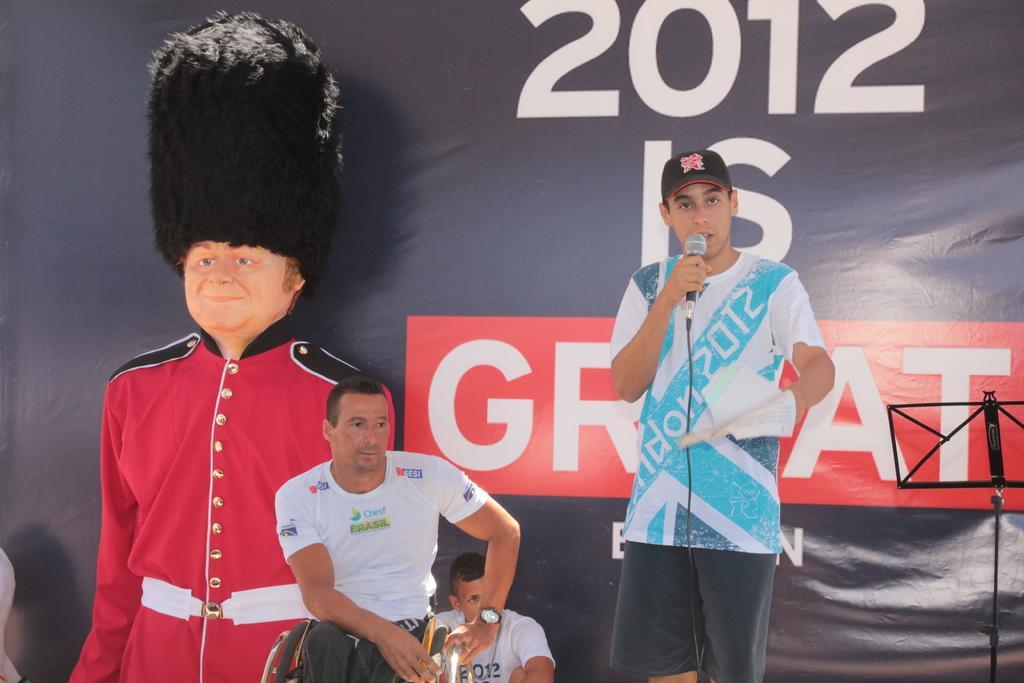Please provide a concise description of this image. In this image I can see few men where one is sitting on a wheel chair and one is standing. I can see all of them are wearing t shirts. Here I can see he is holding a mic, few papers and I can see he is wearing a black cap. In background I can see a black stand, depiction of a man wearing red dress and black hat. I can also see something is written in background and over there I can see one more person is sitting. 